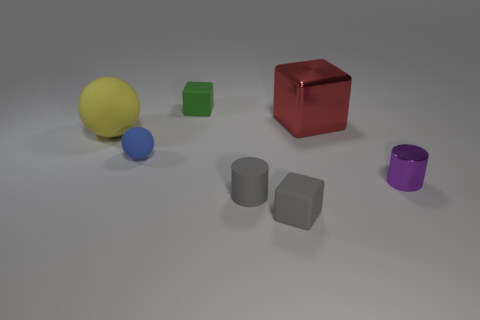Is the number of small blocks greater than the number of green things?
Provide a succinct answer. Yes. How many objects are either tiny metallic cylinders or small rubber blocks that are behind the red thing?
Provide a short and direct response. 2. Is the size of the yellow sphere the same as the red shiny cube?
Ensure brevity in your answer.  Yes. There is a purple thing; are there any small purple shiny objects to the right of it?
Make the answer very short. No. What size is the cube that is in front of the green rubber object and behind the gray matte cylinder?
Make the answer very short. Large. What number of objects are either small brown metal cylinders or gray rubber objects?
Your answer should be very brief. 2. Do the metallic cube and the cylinder that is in front of the metallic cylinder have the same size?
Offer a terse response. No. There is a rubber cube that is on the right side of the green block that is behind the small rubber block in front of the green block; how big is it?
Provide a succinct answer. Small. Is there a purple cube?
Provide a succinct answer. No. What is the material of the small thing that is the same color as the tiny rubber cylinder?
Provide a short and direct response. Rubber. 